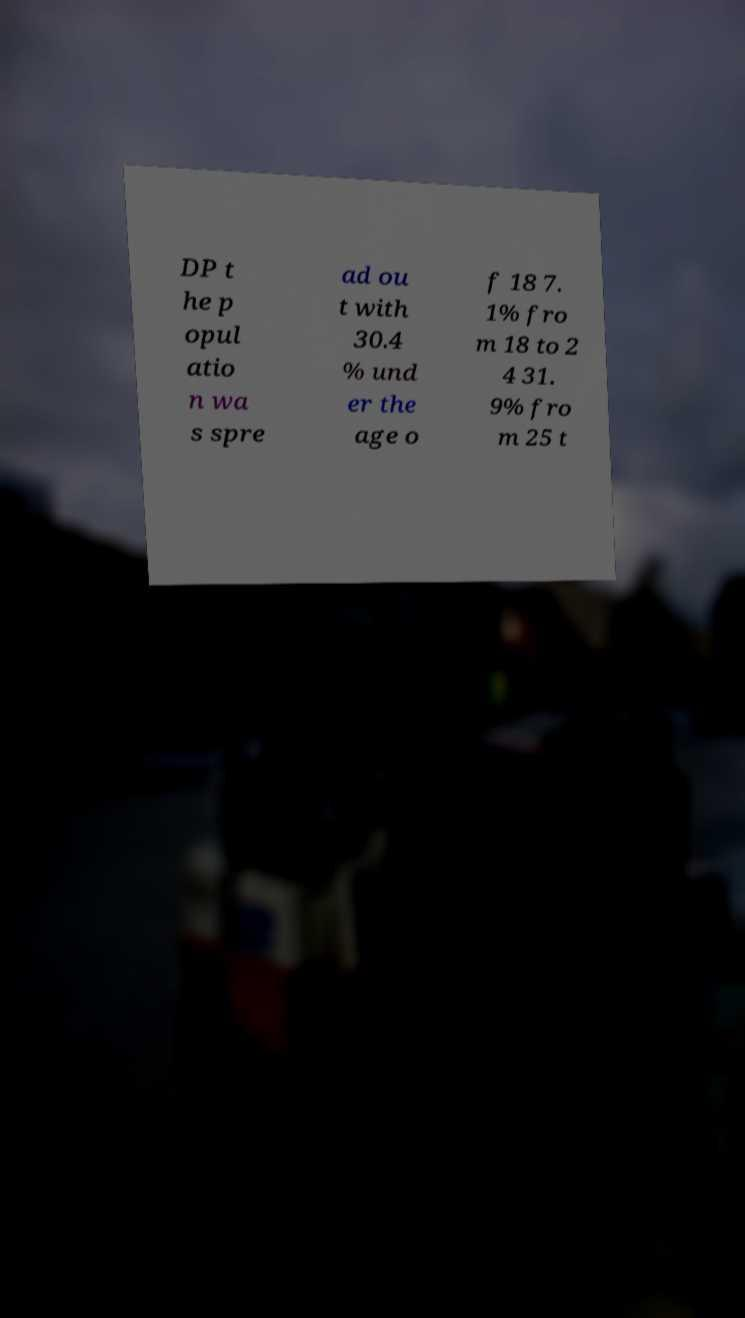I need the written content from this picture converted into text. Can you do that? DP t he p opul atio n wa s spre ad ou t with 30.4 % und er the age o f 18 7. 1% fro m 18 to 2 4 31. 9% fro m 25 t 